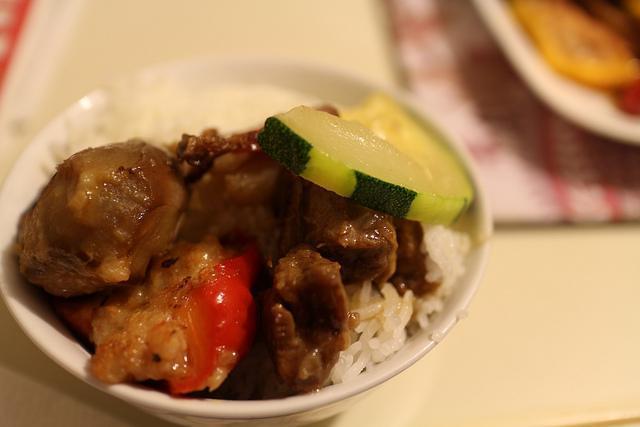How many dining tables are visible?
Give a very brief answer. 1. 